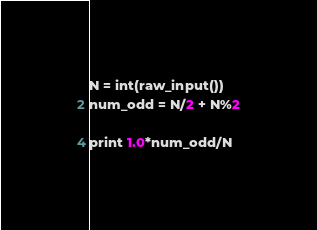Convert code to text. <code><loc_0><loc_0><loc_500><loc_500><_Python_>N = int(raw_input())
num_odd = N/2 + N%2

print 1.0*num_odd/N
</code> 